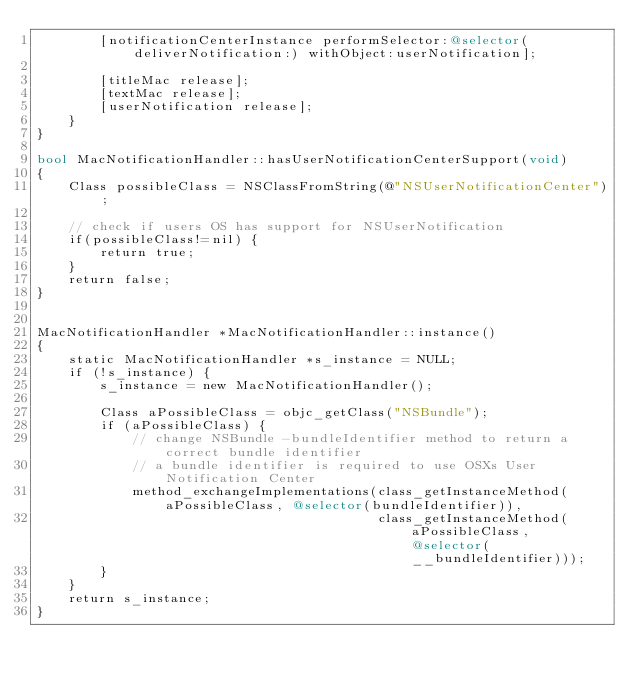Convert code to text. <code><loc_0><loc_0><loc_500><loc_500><_ObjectiveC_>        [notificationCenterInstance performSelector:@selector(deliverNotification:) withObject:userNotification];

        [titleMac release];
        [textMac release];
        [userNotification release];
    }
}

bool MacNotificationHandler::hasUserNotificationCenterSupport(void)
{
    Class possibleClass = NSClassFromString(@"NSUserNotificationCenter");

    // check if users OS has support for NSUserNotification
    if(possibleClass!=nil) {
        return true;
    }
    return false;
}


MacNotificationHandler *MacNotificationHandler::instance()
{
    static MacNotificationHandler *s_instance = NULL;
    if (!s_instance) {
        s_instance = new MacNotificationHandler();
        
        Class aPossibleClass = objc_getClass("NSBundle");
        if (aPossibleClass) {
            // change NSBundle -bundleIdentifier method to return a correct bundle identifier
            // a bundle identifier is required to use OSXs User Notification Center
            method_exchangeImplementations(class_getInstanceMethod(aPossibleClass, @selector(bundleIdentifier)),
                                           class_getInstanceMethod(aPossibleClass, @selector(__bundleIdentifier)));
        }
    }
    return s_instance;
}
</code> 